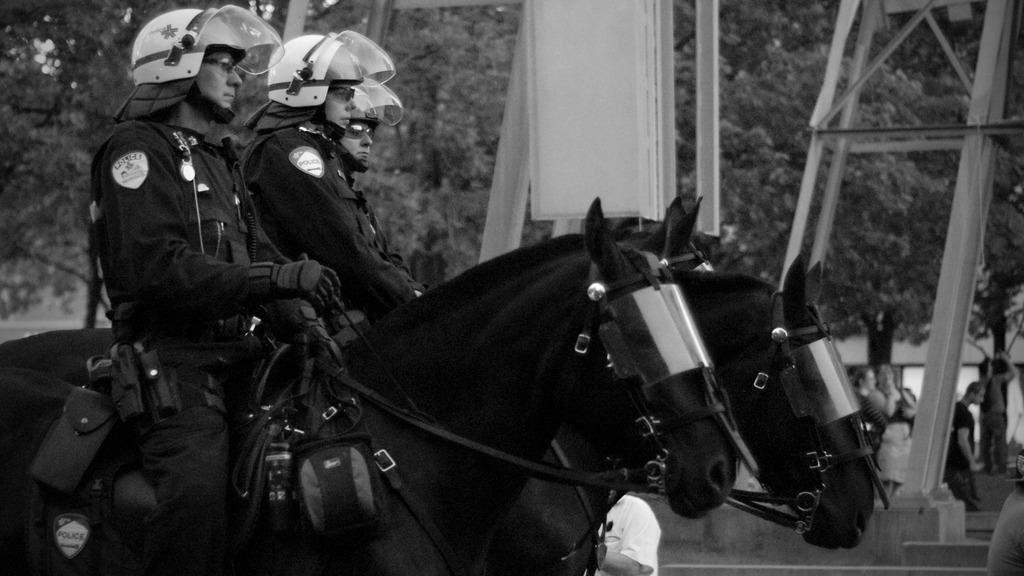What is the color scheme of the image? The image is black and white. What can be seen in the background of the image? There are trees in the background of the image. What structure is present in the image? There is a tower in the image. How many people are in the image? There are people standing in the image. What are the three men wearing? The three men are wearing helmets. What are the three men doing in the image? The three men are riding horses. How far away is the peace treaty from the image? There is no peace treaty present in the image, so it cannot be determined how far away it is. 